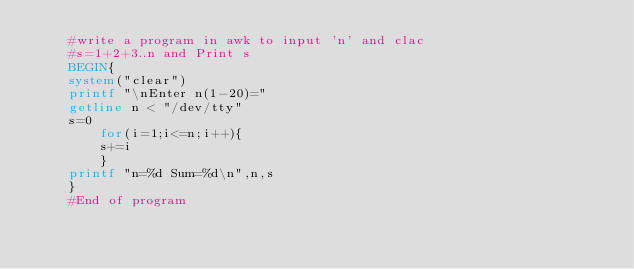Convert code to text. <code><loc_0><loc_0><loc_500><loc_500><_Awk_>	#write a program in awk to input 'n' and clac
	#s=1+2+3..n and Print s
	BEGIN{
	system("clear")
	printf "\nEnter n(1-20)="
	getline n < "/dev/tty"
	s=0
		for(i=1;i<=n;i++){
		s+=i
		}
	printf "n=%d Sum=%d\n",n,s
	}
	#End of program

</code> 